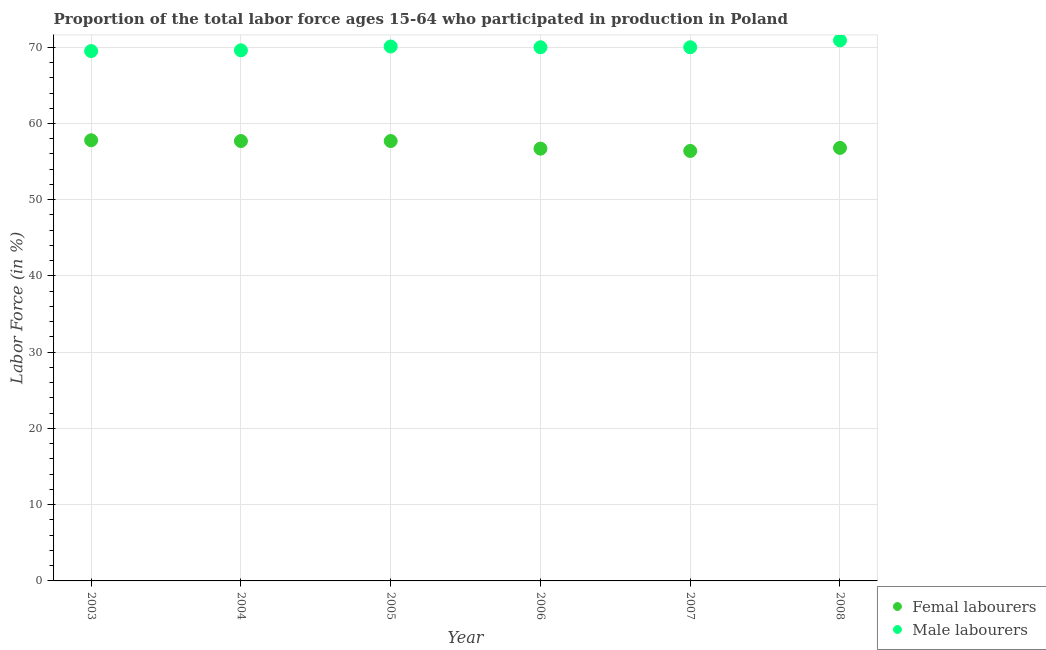How many different coloured dotlines are there?
Your answer should be very brief. 2. What is the percentage of female labor force in 2008?
Offer a very short reply. 56.8. Across all years, what is the maximum percentage of male labour force?
Your answer should be compact. 70.9. Across all years, what is the minimum percentage of male labour force?
Your answer should be very brief. 69.5. In which year was the percentage of female labor force maximum?
Keep it short and to the point. 2003. In which year was the percentage of female labor force minimum?
Make the answer very short. 2007. What is the total percentage of male labour force in the graph?
Your response must be concise. 420.1. What is the difference between the percentage of male labour force in 2003 and that in 2007?
Your response must be concise. -0.5. What is the difference between the percentage of female labor force in 2005 and the percentage of male labour force in 2004?
Provide a short and direct response. -11.9. What is the average percentage of female labor force per year?
Provide a succinct answer. 57.18. In the year 2005, what is the difference between the percentage of female labor force and percentage of male labour force?
Provide a short and direct response. -12.4. What is the ratio of the percentage of male labour force in 2004 to that in 2008?
Keep it short and to the point. 0.98. Is the difference between the percentage of female labor force in 2005 and 2007 greater than the difference between the percentage of male labour force in 2005 and 2007?
Your response must be concise. Yes. What is the difference between the highest and the second highest percentage of male labour force?
Make the answer very short. 0.8. What is the difference between the highest and the lowest percentage of male labour force?
Ensure brevity in your answer.  1.4. In how many years, is the percentage of female labor force greater than the average percentage of female labor force taken over all years?
Keep it short and to the point. 3. Is the percentage of male labour force strictly less than the percentage of female labor force over the years?
Provide a succinct answer. No. How many legend labels are there?
Provide a short and direct response. 2. What is the title of the graph?
Offer a terse response. Proportion of the total labor force ages 15-64 who participated in production in Poland. Does "Primary completion rate" appear as one of the legend labels in the graph?
Your response must be concise. No. What is the label or title of the X-axis?
Offer a very short reply. Year. What is the Labor Force (in %) of Femal labourers in 2003?
Your answer should be very brief. 57.8. What is the Labor Force (in %) of Male labourers in 2003?
Your answer should be compact. 69.5. What is the Labor Force (in %) in Femal labourers in 2004?
Offer a terse response. 57.7. What is the Labor Force (in %) of Male labourers in 2004?
Make the answer very short. 69.6. What is the Labor Force (in %) in Femal labourers in 2005?
Your response must be concise. 57.7. What is the Labor Force (in %) in Male labourers in 2005?
Give a very brief answer. 70.1. What is the Labor Force (in %) of Femal labourers in 2006?
Provide a succinct answer. 56.7. What is the Labor Force (in %) in Male labourers in 2006?
Offer a very short reply. 70. What is the Labor Force (in %) of Femal labourers in 2007?
Give a very brief answer. 56.4. What is the Labor Force (in %) in Femal labourers in 2008?
Make the answer very short. 56.8. What is the Labor Force (in %) of Male labourers in 2008?
Make the answer very short. 70.9. Across all years, what is the maximum Labor Force (in %) in Femal labourers?
Your answer should be compact. 57.8. Across all years, what is the maximum Labor Force (in %) of Male labourers?
Offer a terse response. 70.9. Across all years, what is the minimum Labor Force (in %) in Femal labourers?
Make the answer very short. 56.4. Across all years, what is the minimum Labor Force (in %) of Male labourers?
Ensure brevity in your answer.  69.5. What is the total Labor Force (in %) in Femal labourers in the graph?
Your answer should be compact. 343.1. What is the total Labor Force (in %) of Male labourers in the graph?
Your answer should be very brief. 420.1. What is the difference between the Labor Force (in %) of Femal labourers in 2003 and that in 2004?
Offer a very short reply. 0.1. What is the difference between the Labor Force (in %) in Femal labourers in 2003 and that in 2005?
Offer a very short reply. 0.1. What is the difference between the Labor Force (in %) in Femal labourers in 2003 and that in 2007?
Your answer should be compact. 1.4. What is the difference between the Labor Force (in %) in Femal labourers in 2003 and that in 2008?
Give a very brief answer. 1. What is the difference between the Labor Force (in %) of Male labourers in 2003 and that in 2008?
Ensure brevity in your answer.  -1.4. What is the difference between the Labor Force (in %) of Femal labourers in 2004 and that in 2005?
Your answer should be compact. 0. What is the difference between the Labor Force (in %) in Male labourers in 2004 and that in 2005?
Give a very brief answer. -0.5. What is the difference between the Labor Force (in %) in Male labourers in 2004 and that in 2006?
Keep it short and to the point. -0.4. What is the difference between the Labor Force (in %) in Femal labourers in 2004 and that in 2007?
Give a very brief answer. 1.3. What is the difference between the Labor Force (in %) in Male labourers in 2004 and that in 2007?
Ensure brevity in your answer.  -0.4. What is the difference between the Labor Force (in %) in Femal labourers in 2005 and that in 2006?
Your answer should be compact. 1. What is the difference between the Labor Force (in %) in Femal labourers in 2005 and that in 2008?
Offer a terse response. 0.9. What is the difference between the Labor Force (in %) in Male labourers in 2006 and that in 2007?
Make the answer very short. 0. What is the difference between the Labor Force (in %) in Male labourers in 2006 and that in 2008?
Your response must be concise. -0.9. What is the difference between the Labor Force (in %) of Male labourers in 2007 and that in 2008?
Ensure brevity in your answer.  -0.9. What is the difference between the Labor Force (in %) of Femal labourers in 2003 and the Labor Force (in %) of Male labourers in 2006?
Keep it short and to the point. -12.2. What is the difference between the Labor Force (in %) in Femal labourers in 2003 and the Labor Force (in %) in Male labourers in 2007?
Ensure brevity in your answer.  -12.2. What is the difference between the Labor Force (in %) of Femal labourers in 2004 and the Labor Force (in %) of Male labourers in 2005?
Your answer should be compact. -12.4. What is the difference between the Labor Force (in %) in Femal labourers in 2004 and the Labor Force (in %) in Male labourers in 2006?
Keep it short and to the point. -12.3. What is the difference between the Labor Force (in %) in Femal labourers in 2004 and the Labor Force (in %) in Male labourers in 2008?
Make the answer very short. -13.2. What is the difference between the Labor Force (in %) of Femal labourers in 2005 and the Labor Force (in %) of Male labourers in 2007?
Provide a short and direct response. -12.3. What is the difference between the Labor Force (in %) in Femal labourers in 2005 and the Labor Force (in %) in Male labourers in 2008?
Give a very brief answer. -13.2. What is the difference between the Labor Force (in %) in Femal labourers in 2007 and the Labor Force (in %) in Male labourers in 2008?
Give a very brief answer. -14.5. What is the average Labor Force (in %) in Femal labourers per year?
Provide a succinct answer. 57.18. What is the average Labor Force (in %) of Male labourers per year?
Your answer should be very brief. 70.02. In the year 2004, what is the difference between the Labor Force (in %) of Femal labourers and Labor Force (in %) of Male labourers?
Your answer should be very brief. -11.9. In the year 2005, what is the difference between the Labor Force (in %) in Femal labourers and Labor Force (in %) in Male labourers?
Your response must be concise. -12.4. In the year 2006, what is the difference between the Labor Force (in %) of Femal labourers and Labor Force (in %) of Male labourers?
Provide a succinct answer. -13.3. In the year 2008, what is the difference between the Labor Force (in %) in Femal labourers and Labor Force (in %) in Male labourers?
Offer a very short reply. -14.1. What is the ratio of the Labor Force (in %) of Male labourers in 2003 to that in 2005?
Offer a terse response. 0.99. What is the ratio of the Labor Force (in %) of Femal labourers in 2003 to that in 2006?
Your answer should be very brief. 1.02. What is the ratio of the Labor Force (in %) of Femal labourers in 2003 to that in 2007?
Give a very brief answer. 1.02. What is the ratio of the Labor Force (in %) of Male labourers in 2003 to that in 2007?
Offer a very short reply. 0.99. What is the ratio of the Labor Force (in %) of Femal labourers in 2003 to that in 2008?
Give a very brief answer. 1.02. What is the ratio of the Labor Force (in %) of Male labourers in 2003 to that in 2008?
Your answer should be very brief. 0.98. What is the ratio of the Labor Force (in %) in Femal labourers in 2004 to that in 2005?
Make the answer very short. 1. What is the ratio of the Labor Force (in %) in Femal labourers in 2004 to that in 2006?
Your response must be concise. 1.02. What is the ratio of the Labor Force (in %) of Male labourers in 2004 to that in 2006?
Offer a terse response. 0.99. What is the ratio of the Labor Force (in %) in Male labourers in 2004 to that in 2007?
Ensure brevity in your answer.  0.99. What is the ratio of the Labor Force (in %) in Femal labourers in 2004 to that in 2008?
Provide a short and direct response. 1.02. What is the ratio of the Labor Force (in %) of Male labourers in 2004 to that in 2008?
Your answer should be very brief. 0.98. What is the ratio of the Labor Force (in %) in Femal labourers in 2005 to that in 2006?
Your response must be concise. 1.02. What is the ratio of the Labor Force (in %) in Male labourers in 2005 to that in 2006?
Provide a short and direct response. 1. What is the ratio of the Labor Force (in %) in Femal labourers in 2005 to that in 2007?
Offer a very short reply. 1.02. What is the ratio of the Labor Force (in %) of Male labourers in 2005 to that in 2007?
Ensure brevity in your answer.  1. What is the ratio of the Labor Force (in %) in Femal labourers in 2005 to that in 2008?
Make the answer very short. 1.02. What is the ratio of the Labor Force (in %) of Male labourers in 2005 to that in 2008?
Your response must be concise. 0.99. What is the ratio of the Labor Force (in %) of Male labourers in 2006 to that in 2008?
Your answer should be compact. 0.99. What is the ratio of the Labor Force (in %) of Femal labourers in 2007 to that in 2008?
Ensure brevity in your answer.  0.99. What is the ratio of the Labor Force (in %) in Male labourers in 2007 to that in 2008?
Ensure brevity in your answer.  0.99. What is the difference between the highest and the second highest Labor Force (in %) of Femal labourers?
Keep it short and to the point. 0.1. What is the difference between the highest and the second highest Labor Force (in %) in Male labourers?
Offer a very short reply. 0.8. What is the difference between the highest and the lowest Labor Force (in %) in Male labourers?
Give a very brief answer. 1.4. 